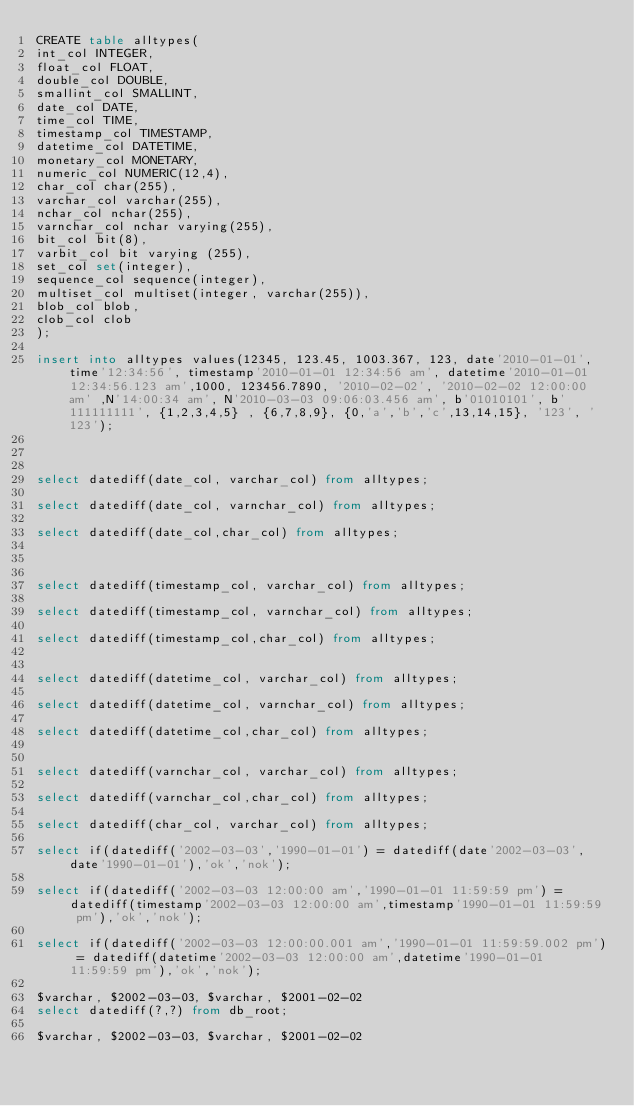<code> <loc_0><loc_0><loc_500><loc_500><_SQL_>CREATE table alltypes(
int_col INTEGER,
float_col FLOAT,
double_col DOUBLE,
smallint_col SMALLINT,
date_col DATE,
time_col TIME,
timestamp_col TIMESTAMP,
datetime_col DATETIME,
monetary_col MONETARY,
numeric_col NUMERIC(12,4),
char_col char(255),
varchar_col varchar(255),
nchar_col nchar(255),
varnchar_col nchar varying(255),
bit_col bit(8),
varbit_col bit varying (255),
set_col set(integer),
sequence_col sequence(integer),
multiset_col multiset(integer, varchar(255)),
blob_col blob,
clob_col clob
);

insert into alltypes values(12345, 123.45, 1003.367, 123, date'2010-01-01', time'12:34:56', timestamp'2010-01-01 12:34:56 am', datetime'2010-01-01 12:34:56.123 am',1000, 123456.7890, '2010-02-02', '2010-02-02 12:00:00 am' ,N'14:00:34 am', N'2010-03-03 09:06:03.456 am', b'01010101', b'111111111', {1,2,3,4,5} , {6,7,8,9}, {0,'a','b','c',13,14,15}, '123', '123');



select datediff(date_col, varchar_col) from alltypes;

select datediff(date_col, varnchar_col) from alltypes;

select datediff(date_col,char_col) from alltypes;



select datediff(timestamp_col, varchar_col) from alltypes;

select datediff(timestamp_col, varnchar_col) from alltypes;

select datediff(timestamp_col,char_col) from alltypes;


select datediff(datetime_col, varchar_col) from alltypes;

select datediff(datetime_col, varnchar_col) from alltypes;

select datediff(datetime_col,char_col) from alltypes;


select datediff(varnchar_col, varchar_col) from alltypes;

select datediff(varnchar_col,char_col) from alltypes;

select datediff(char_col, varchar_col) from alltypes;

select if(datediff('2002-03-03','1990-01-01') = datediff(date'2002-03-03',date'1990-01-01'),'ok','nok');

select if(datediff('2002-03-03 12:00:00 am','1990-01-01 11:59:59 pm') = datediff(timestamp'2002-03-03 12:00:00 am',timestamp'1990-01-01 11:59:59 pm'),'ok','nok');

select if(datediff('2002-03-03 12:00:00.001 am','1990-01-01 11:59:59.002 pm') = datediff(datetime'2002-03-03 12:00:00 am',datetime'1990-01-01 11:59:59 pm'),'ok','nok');

$varchar, $2002-03-03, $varchar, $2001-02-02
select datediff(?,?) from db_root;

$varchar, $2002-03-03, $varchar, $2001-02-02</code> 